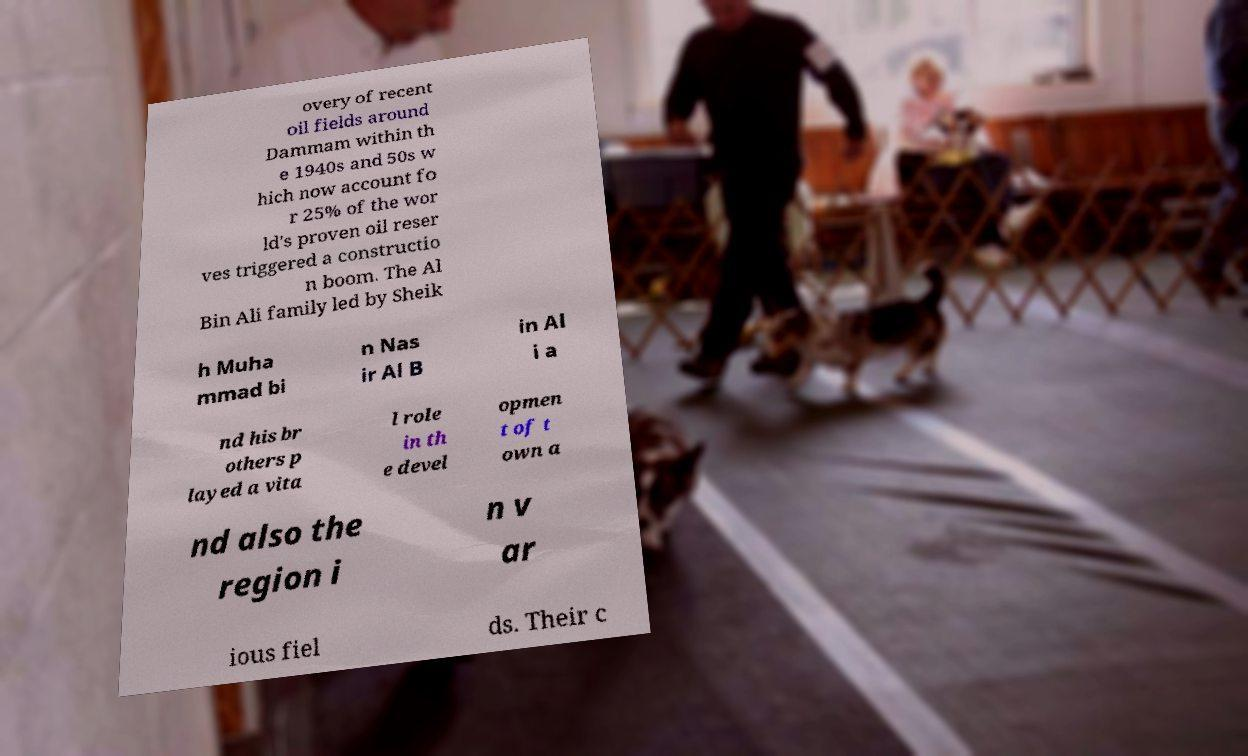I need the written content from this picture converted into text. Can you do that? overy of recent oil fields around Dammam within th e 1940s and 50s w hich now account fo r 25% of the wor ld's proven oil reser ves triggered a constructio n boom. The Al Bin Ali family led by Sheik h Muha mmad bi n Nas ir Al B in Al i a nd his br others p layed a vita l role in th e devel opmen t of t own a nd also the region i n v ar ious fiel ds. Their c 